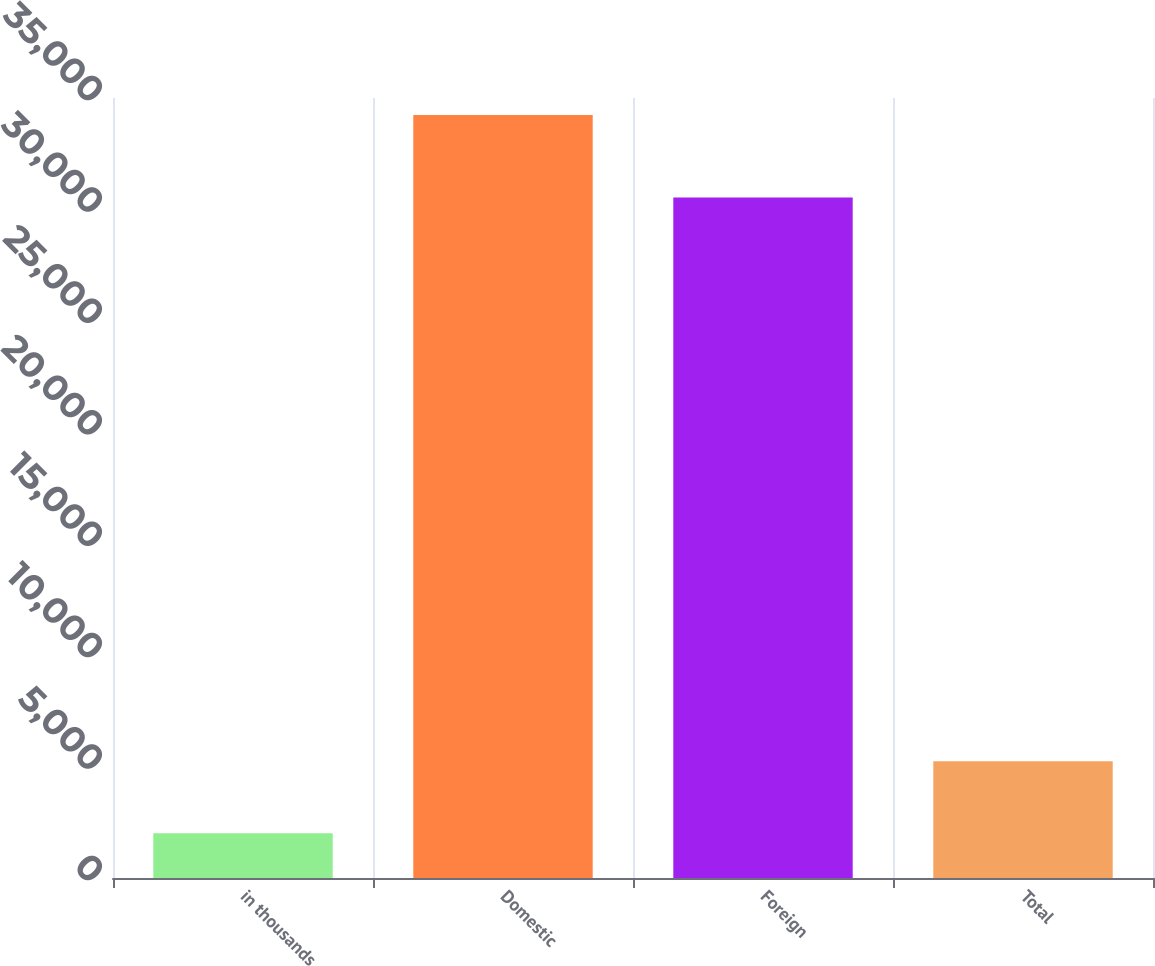Convert chart. <chart><loc_0><loc_0><loc_500><loc_500><bar_chart><fcel>in thousands<fcel>Domestic<fcel>Foreign<fcel>Total<nl><fcel>2013<fcel>34239<fcel>30536<fcel>5235.6<nl></chart> 